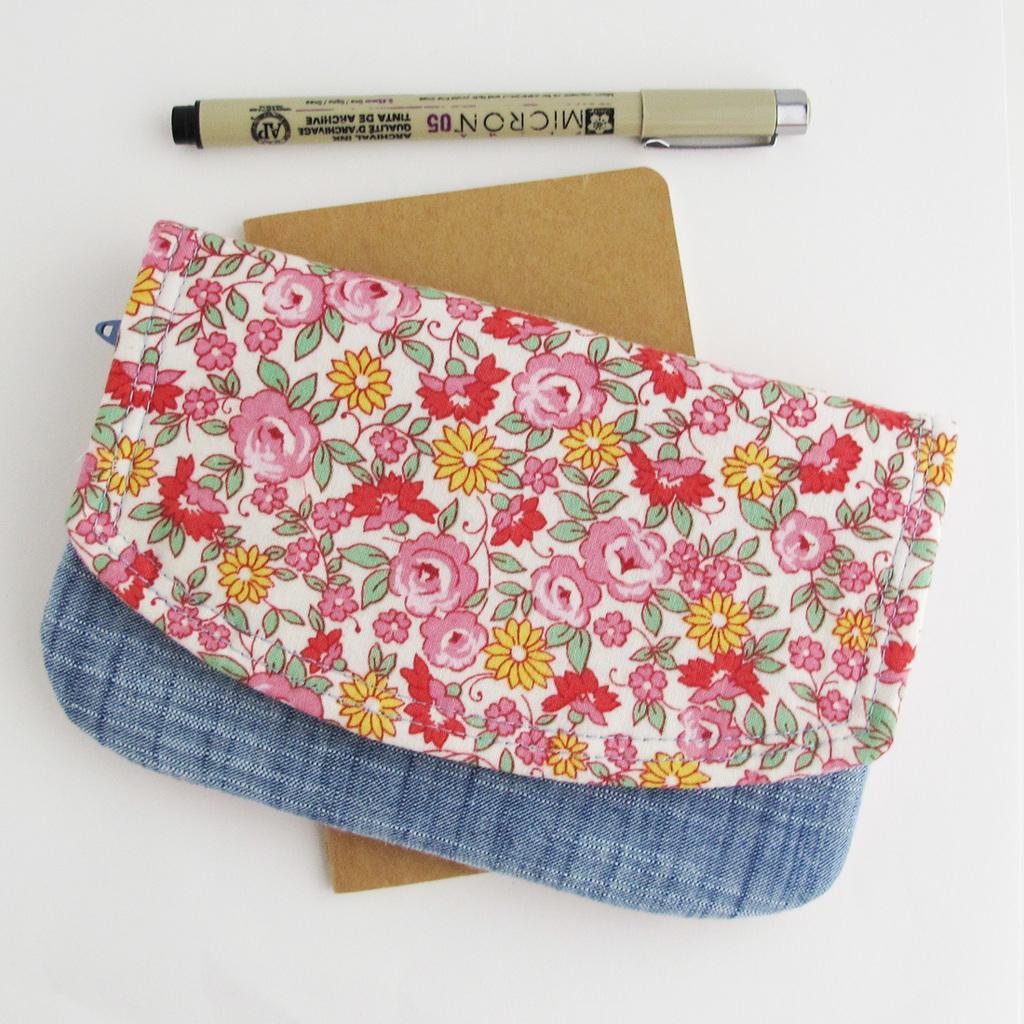How would you summarize this image in a sentence or two? In this image I can see a colorful purse which is in blue,pink,red and yellow color. We can see brown color board and pen. 